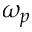Convert formula to latex. <formula><loc_0><loc_0><loc_500><loc_500>\omega _ { p }</formula> 